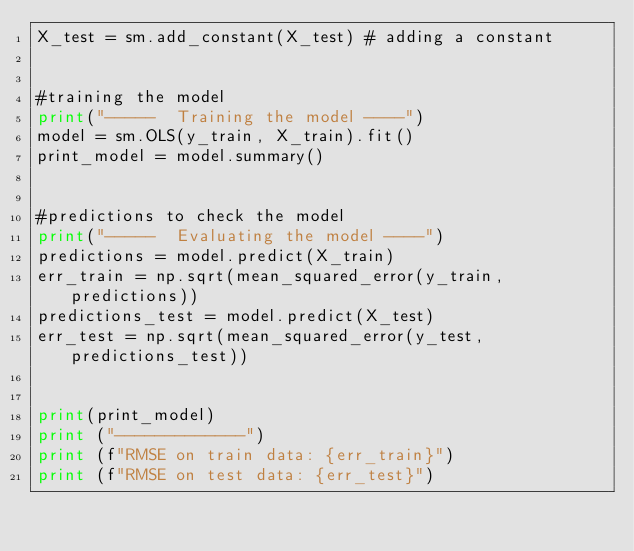Convert code to text. <code><loc_0><loc_0><loc_500><loc_500><_Python_>X_test = sm.add_constant(X_test) # adding a constant


#training the model
print("-----  Training the model ----")
model = sm.OLS(y_train, X_train).fit()
print_model = model.summary()


#predictions to check the model
print("-----  Evaluating the model ----")
predictions = model.predict(X_train)
err_train = np.sqrt(mean_squared_error(y_train, predictions))
predictions_test = model.predict(X_test)
err_test = np.sqrt(mean_squared_error(y_test, predictions_test))


print(print_model)
print ("-------------")
print (f"RMSE on train data: {err_train}")
print (f"RMSE on test data: {err_test}")
</code> 